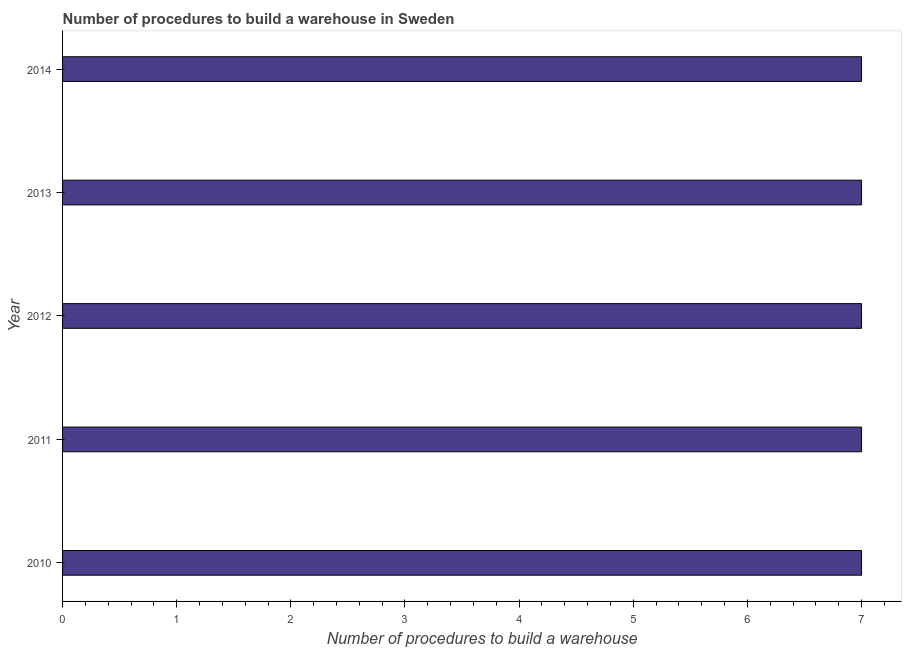What is the title of the graph?
Offer a very short reply. Number of procedures to build a warehouse in Sweden. What is the label or title of the X-axis?
Keep it short and to the point. Number of procedures to build a warehouse. What is the label or title of the Y-axis?
Provide a succinct answer. Year. Across all years, what is the minimum number of procedures to build a warehouse?
Your response must be concise. 7. What is the sum of the number of procedures to build a warehouse?
Give a very brief answer. 35. What is the difference between the number of procedures to build a warehouse in 2010 and 2011?
Provide a succinct answer. 0. Do a majority of the years between 2010 and 2012 (inclusive) have number of procedures to build a warehouse greater than 2.2 ?
Give a very brief answer. Yes. What is the ratio of the number of procedures to build a warehouse in 2010 to that in 2011?
Your answer should be compact. 1. What is the difference between the highest and the second highest number of procedures to build a warehouse?
Your response must be concise. 0. Is the sum of the number of procedures to build a warehouse in 2012 and 2013 greater than the maximum number of procedures to build a warehouse across all years?
Your answer should be compact. Yes. In how many years, is the number of procedures to build a warehouse greater than the average number of procedures to build a warehouse taken over all years?
Provide a succinct answer. 0. How many bars are there?
Keep it short and to the point. 5. How many years are there in the graph?
Offer a terse response. 5. What is the difference between two consecutive major ticks on the X-axis?
Provide a succinct answer. 1. What is the Number of procedures to build a warehouse of 2013?
Your response must be concise. 7. What is the Number of procedures to build a warehouse of 2014?
Provide a succinct answer. 7. What is the difference between the Number of procedures to build a warehouse in 2010 and 2013?
Offer a very short reply. 0. What is the difference between the Number of procedures to build a warehouse in 2010 and 2014?
Your answer should be very brief. 0. What is the difference between the Number of procedures to build a warehouse in 2011 and 2012?
Your answer should be very brief. 0. What is the difference between the Number of procedures to build a warehouse in 2011 and 2014?
Your answer should be compact. 0. What is the ratio of the Number of procedures to build a warehouse in 2010 to that in 2011?
Your answer should be very brief. 1. What is the ratio of the Number of procedures to build a warehouse in 2010 to that in 2012?
Offer a very short reply. 1. What is the ratio of the Number of procedures to build a warehouse in 2010 to that in 2013?
Your answer should be very brief. 1. What is the ratio of the Number of procedures to build a warehouse in 2010 to that in 2014?
Provide a short and direct response. 1. What is the ratio of the Number of procedures to build a warehouse in 2011 to that in 2012?
Provide a succinct answer. 1. What is the ratio of the Number of procedures to build a warehouse in 2011 to that in 2014?
Offer a terse response. 1. What is the ratio of the Number of procedures to build a warehouse in 2012 to that in 2014?
Make the answer very short. 1. What is the ratio of the Number of procedures to build a warehouse in 2013 to that in 2014?
Offer a terse response. 1. 